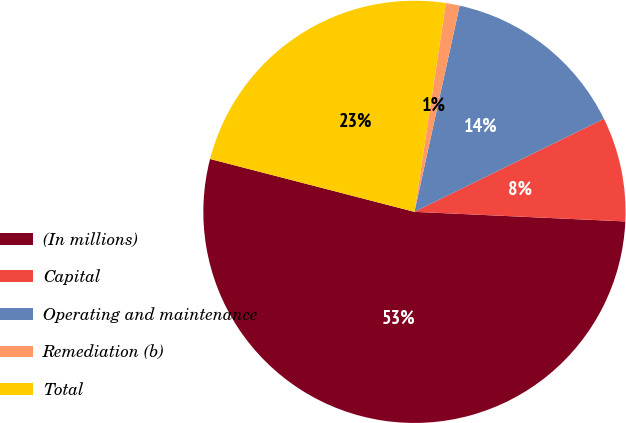<chart> <loc_0><loc_0><loc_500><loc_500><pie_chart><fcel>(In millions)<fcel>Capital<fcel>Operating and maintenance<fcel>Remediation (b)<fcel>Total<nl><fcel>53.31%<fcel>7.99%<fcel>14.3%<fcel>1.06%<fcel>23.35%<nl></chart> 